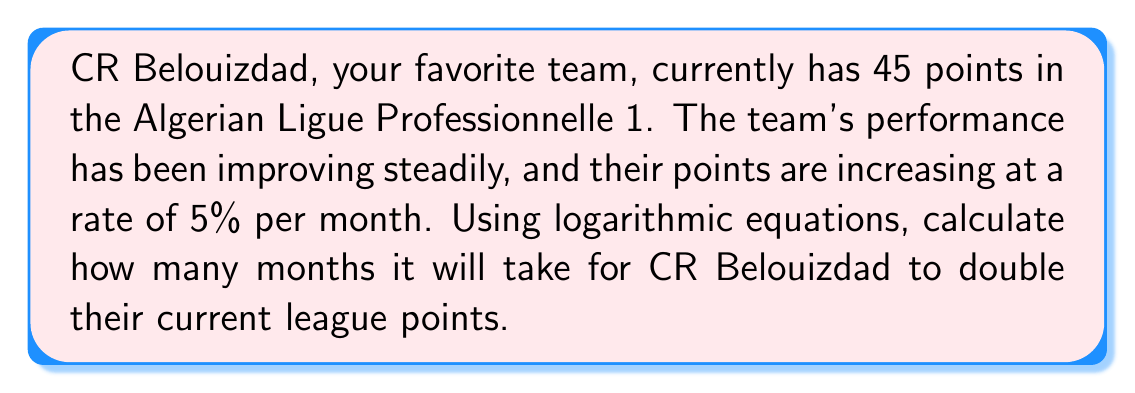Solve this math problem. Let's approach this problem step by step using logarithmic equations:

1) Let $P$ be the initial points (45) and $t$ be the time in months.
2) The growth rate is 5% per month, so the growth factor is $1.05$.
3) We want to find $t$ when the points have doubled, so $2P$.

The exponential growth equation is:

$$2P = P(1.05)^t$$

Simplifying:

$$2 = (1.05)^t$$

Now, we can apply logarithms to both sides. Let's use the natural logarithm (ln):

$$\ln(2) = \ln((1.05)^t)$$

Using the logarithm property $\ln(a^b) = b\ln(a)$:

$$\ln(2) = t\ln(1.05)$$

Now we can solve for $t$:

$$t = \frac{\ln(2)}{\ln(1.05)}$$

Using a calculator or computer:

$$t \approx 14.2067$$

Since we can't have a fractional month in this context, we round up to the nearest whole month.
Answer: It will take 15 months for CR Belouizdad to double its current league points. 